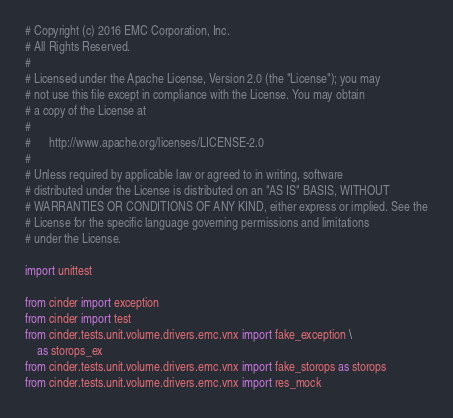Convert code to text. <code><loc_0><loc_0><loc_500><loc_500><_Python_># Copyright (c) 2016 EMC Corporation, Inc.
# All Rights Reserved.
#
# Licensed under the Apache License, Version 2.0 (the "License"); you may
# not use this file except in compliance with the License. You may obtain
# a copy of the License at
#
#      http://www.apache.org/licenses/LICENSE-2.0
#
# Unless required by applicable law or agreed to in writing, software
# distributed under the License is distributed on an "AS IS" BASIS, WITHOUT
# WARRANTIES OR CONDITIONS OF ANY KIND, either express or implied. See the
# License for the specific language governing permissions and limitations
# under the License.

import unittest

from cinder import exception
from cinder import test
from cinder.tests.unit.volume.drivers.emc.vnx import fake_exception \
    as storops_ex
from cinder.tests.unit.volume.drivers.emc.vnx import fake_storops as storops
from cinder.tests.unit.volume.drivers.emc.vnx import res_mock</code> 